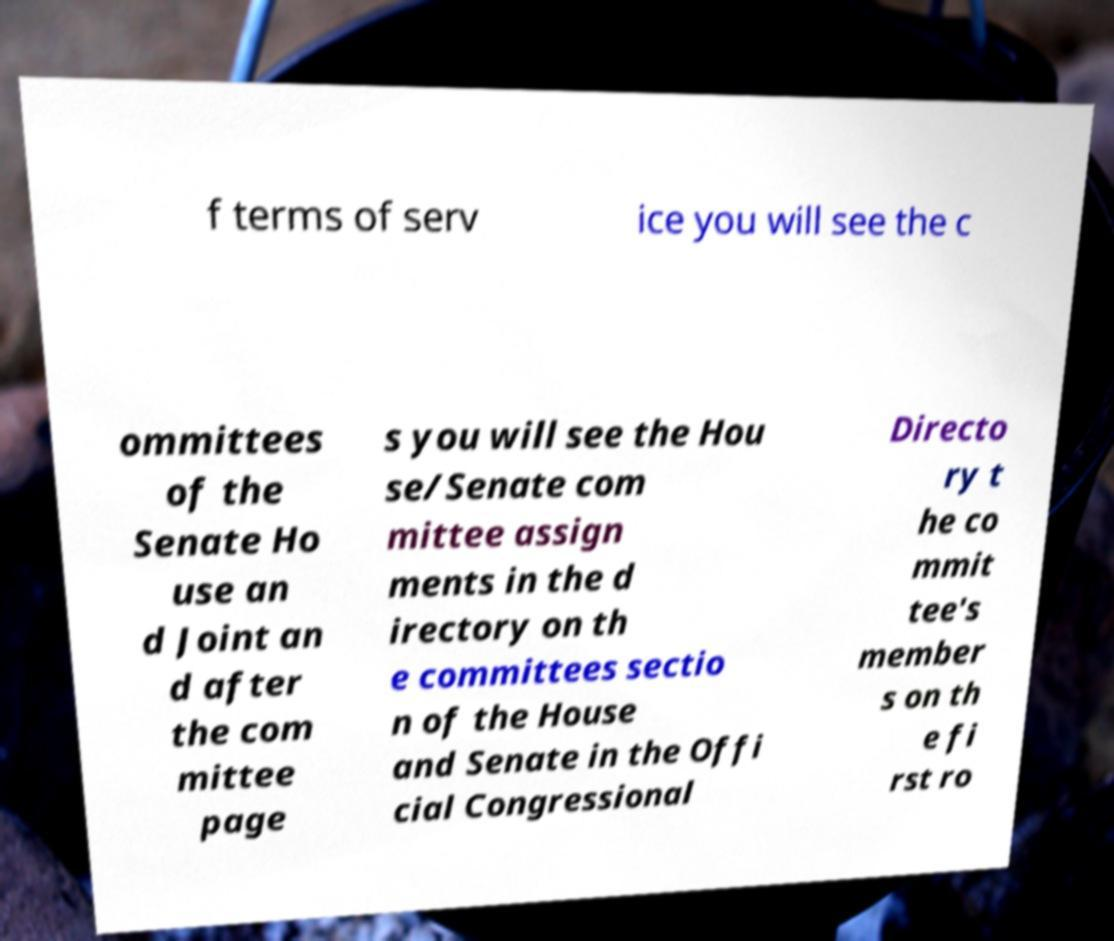Could you extract and type out the text from this image? f terms of serv ice you will see the c ommittees of the Senate Ho use an d Joint an d after the com mittee page s you will see the Hou se/Senate com mittee assign ments in the d irectory on th e committees sectio n of the House and Senate in the Offi cial Congressional Directo ry t he co mmit tee's member s on th e fi rst ro 